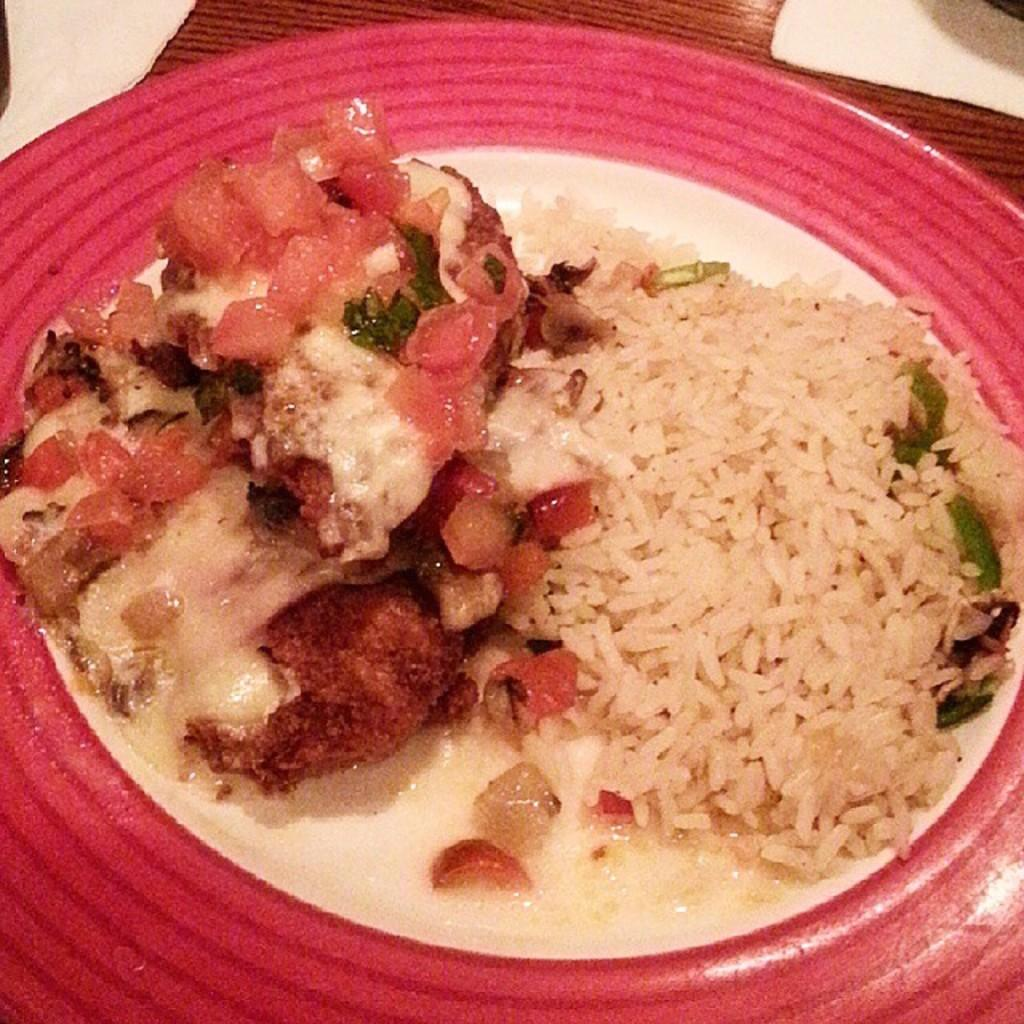What is on the serving plate in the image? The serving plate contains food. Where is the serving plate located in the image? The serving plate is placed on a table. What type of brush is being used to paint the news on the table in the image? There is no brush or news present in the image; it only features a serving plate with food on a table. 